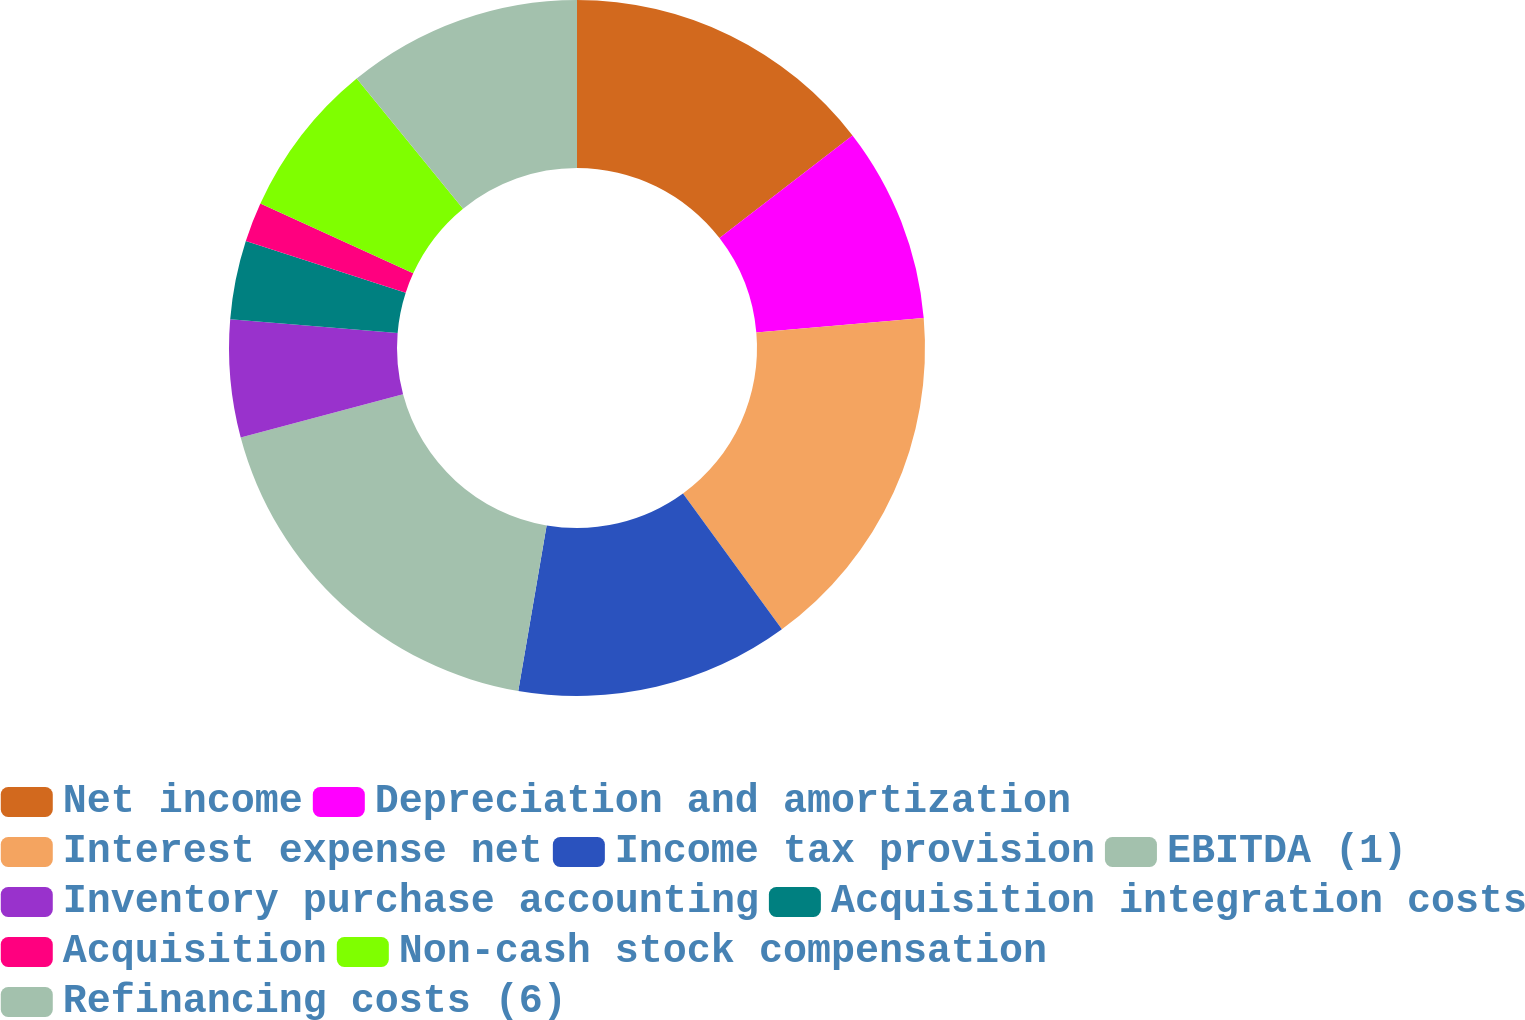<chart> <loc_0><loc_0><loc_500><loc_500><pie_chart><fcel>Net income<fcel>Depreciation and amortization<fcel>Interest expense net<fcel>Income tax provision<fcel>EBITDA (1)<fcel>Inventory purchase accounting<fcel>Acquisition integration costs<fcel>Acquisition<fcel>Non-cash stock compensation<fcel>Refinancing costs (6)<nl><fcel>14.54%<fcel>9.09%<fcel>16.35%<fcel>12.72%<fcel>18.16%<fcel>5.46%<fcel>3.65%<fcel>1.84%<fcel>7.28%<fcel>10.91%<nl></chart> 